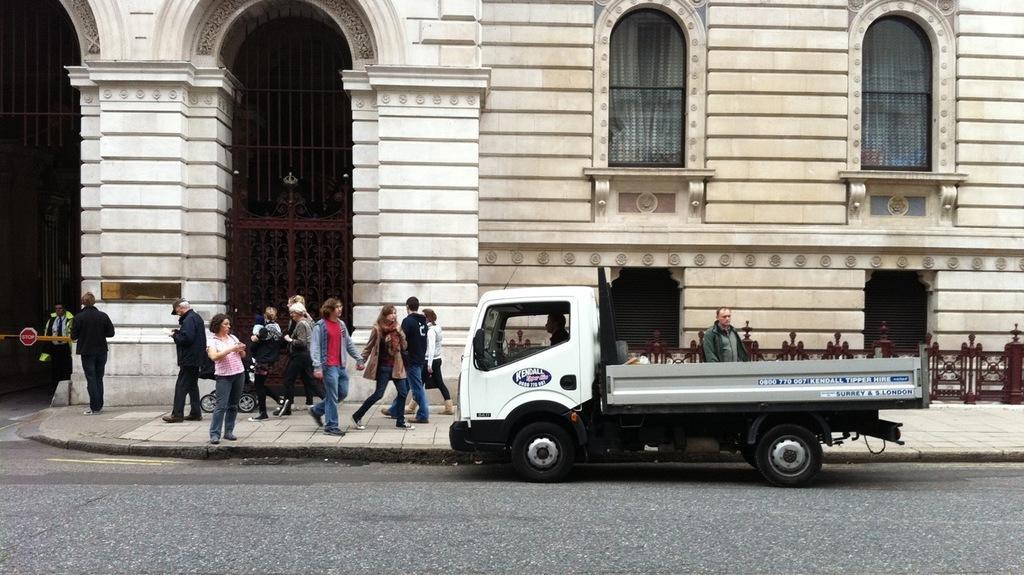In one or two sentences, can you explain what this image depicts? In this image i can see a vehicle, a person sitting in it, at the back ground i can see few people walking on the path way, at the back side i can see a building. 